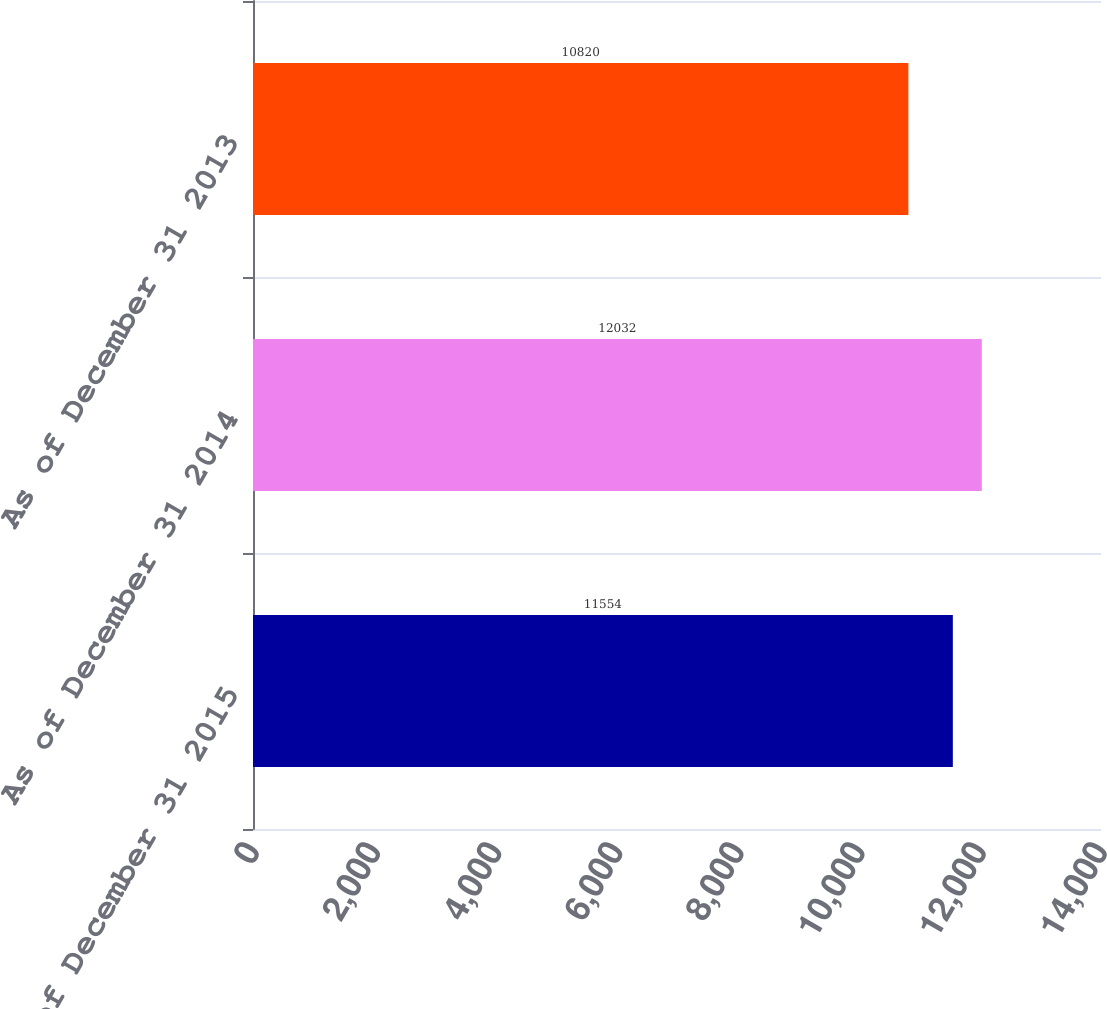Convert chart to OTSL. <chart><loc_0><loc_0><loc_500><loc_500><bar_chart><fcel>As of December 31 2015<fcel>As of December 31 2014<fcel>As of December 31 2013<nl><fcel>11554<fcel>12032<fcel>10820<nl></chart> 